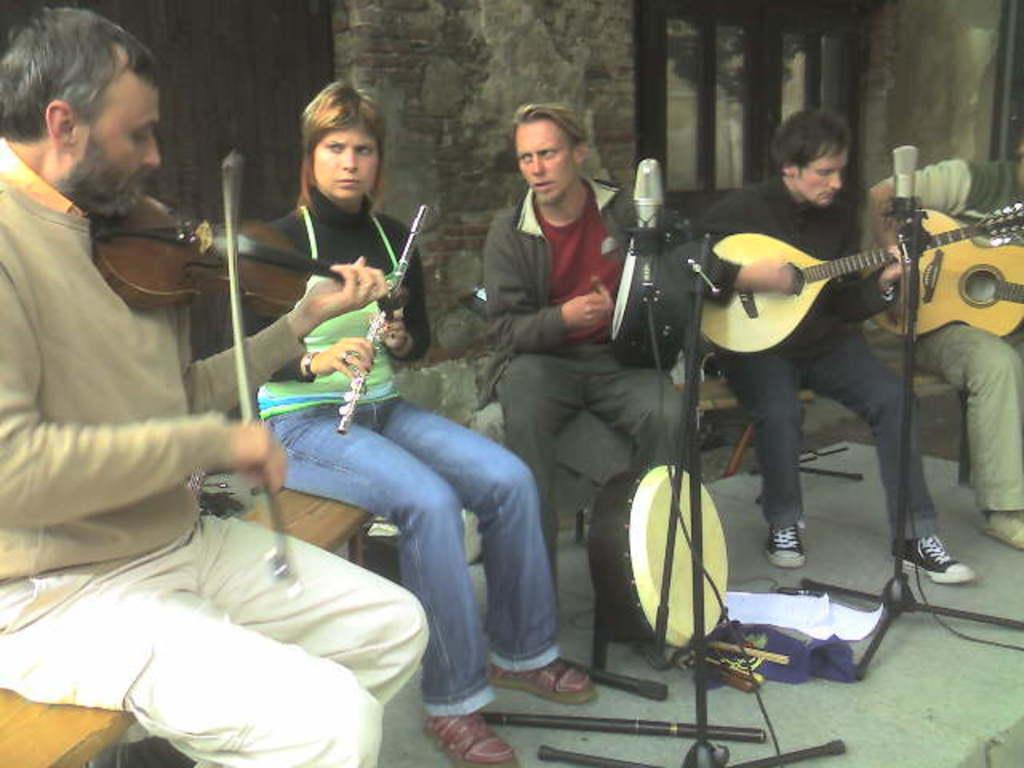How many people are present in the image? There are five people in the image. What are the people doing in the image? The people are playing a guitar. What type of chair are the people sitting on? The people are sitting on a wooden chair. What type of trousers are the chickens wearing in the image? There are no chickens present in the image, and therefore no trousers can be observed. 